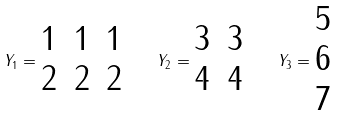Convert formula to latex. <formula><loc_0><loc_0><loc_500><loc_500>Y _ { 1 } = \begin{matrix} 1 & 1 & 1 \\ 2 & 2 & 2 \end{matrix} \quad Y _ { 2 } = \begin{matrix} 3 & 3 \\ 4 & 4 \end{matrix} \quad Y _ { 3 } = \begin{matrix} 5 \\ 6 \\ 7 \end{matrix}</formula> 